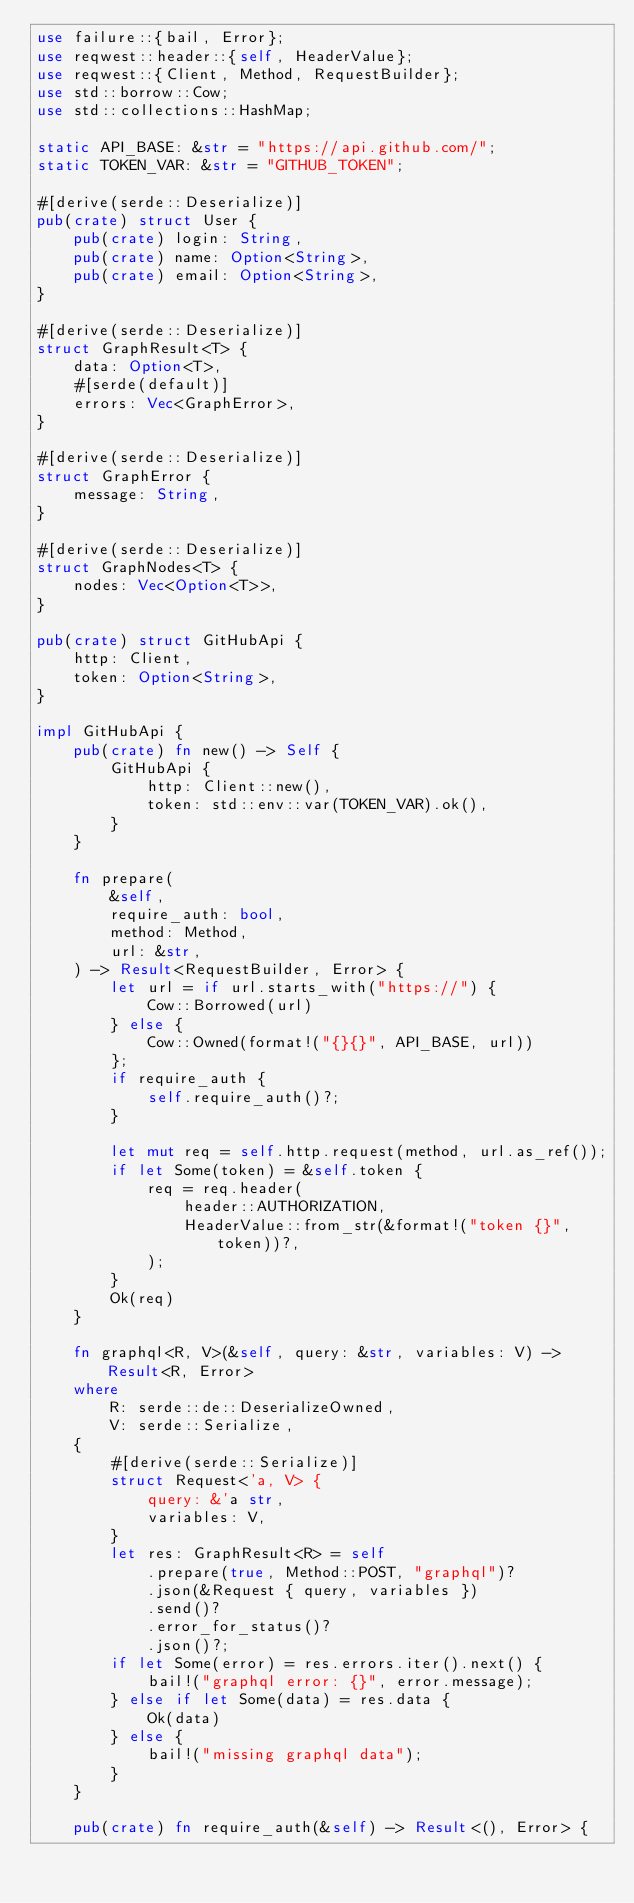Convert code to text. <code><loc_0><loc_0><loc_500><loc_500><_Rust_>use failure::{bail, Error};
use reqwest::header::{self, HeaderValue};
use reqwest::{Client, Method, RequestBuilder};
use std::borrow::Cow;
use std::collections::HashMap;

static API_BASE: &str = "https://api.github.com/";
static TOKEN_VAR: &str = "GITHUB_TOKEN";

#[derive(serde::Deserialize)]
pub(crate) struct User {
    pub(crate) login: String,
    pub(crate) name: Option<String>,
    pub(crate) email: Option<String>,
}

#[derive(serde::Deserialize)]
struct GraphResult<T> {
    data: Option<T>,
    #[serde(default)]
    errors: Vec<GraphError>,
}

#[derive(serde::Deserialize)]
struct GraphError {
    message: String,
}

#[derive(serde::Deserialize)]
struct GraphNodes<T> {
    nodes: Vec<Option<T>>,
}

pub(crate) struct GitHubApi {
    http: Client,
    token: Option<String>,
}

impl GitHubApi {
    pub(crate) fn new() -> Self {
        GitHubApi {
            http: Client::new(),
            token: std::env::var(TOKEN_VAR).ok(),
        }
    }

    fn prepare(
        &self,
        require_auth: bool,
        method: Method,
        url: &str,
    ) -> Result<RequestBuilder, Error> {
        let url = if url.starts_with("https://") {
            Cow::Borrowed(url)
        } else {
            Cow::Owned(format!("{}{}", API_BASE, url))
        };
        if require_auth {
            self.require_auth()?;
        }

        let mut req = self.http.request(method, url.as_ref());
        if let Some(token) = &self.token {
            req = req.header(
                header::AUTHORIZATION,
                HeaderValue::from_str(&format!("token {}", token))?,
            );
        }
        Ok(req)
    }

    fn graphql<R, V>(&self, query: &str, variables: V) -> Result<R, Error>
    where
        R: serde::de::DeserializeOwned,
        V: serde::Serialize,
    {
        #[derive(serde::Serialize)]
        struct Request<'a, V> {
            query: &'a str,
            variables: V,
        }
        let res: GraphResult<R> = self
            .prepare(true, Method::POST, "graphql")?
            .json(&Request { query, variables })
            .send()?
            .error_for_status()?
            .json()?;
        if let Some(error) = res.errors.iter().next() {
            bail!("graphql error: {}", error.message);
        } else if let Some(data) = res.data {
            Ok(data)
        } else {
            bail!("missing graphql data");
        }
    }

    pub(crate) fn require_auth(&self) -> Result<(), Error> {</code> 